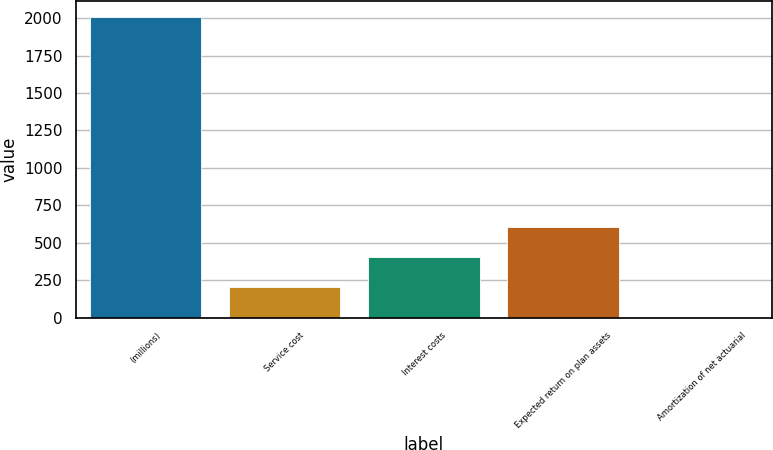<chart> <loc_0><loc_0><loc_500><loc_500><bar_chart><fcel>(millions)<fcel>Service cost<fcel>Interest costs<fcel>Expected return on plan assets<fcel>Amortization of net actuarial<nl><fcel>2011<fcel>203.08<fcel>403.96<fcel>604.84<fcel>2.2<nl></chart> 